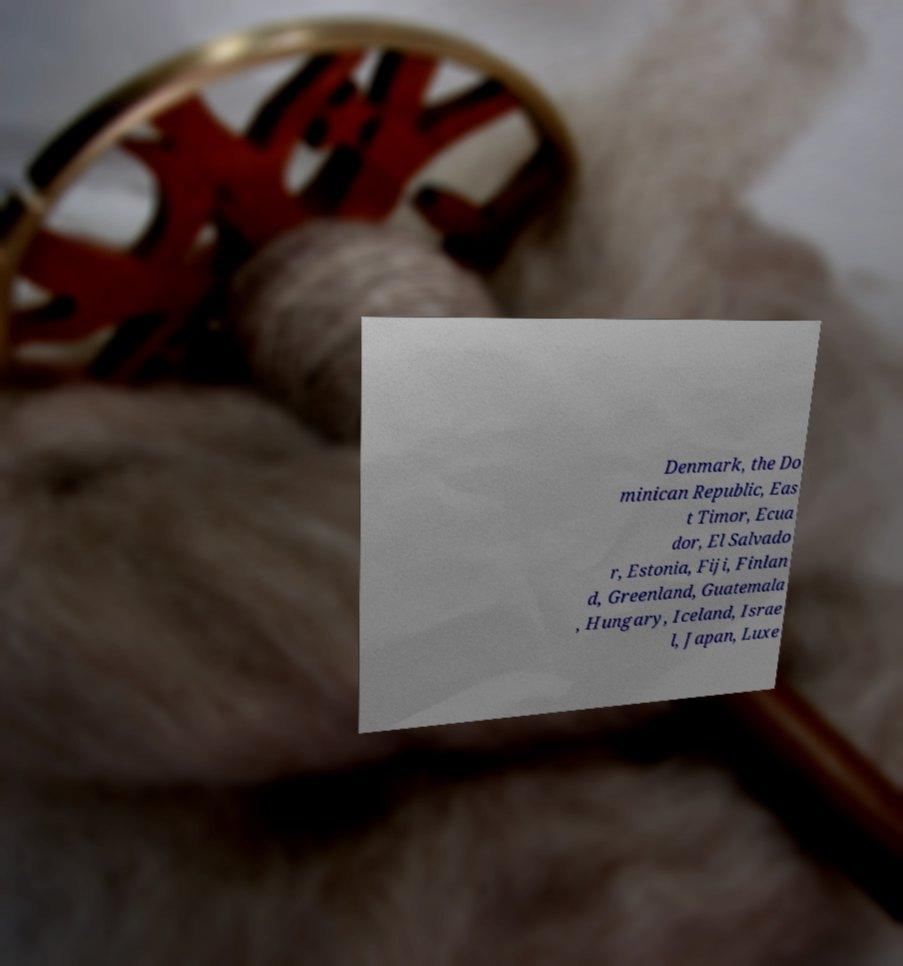Could you extract and type out the text from this image? Denmark, the Do minican Republic, Eas t Timor, Ecua dor, El Salvado r, Estonia, Fiji, Finlan d, Greenland, Guatemala , Hungary, Iceland, Israe l, Japan, Luxe 